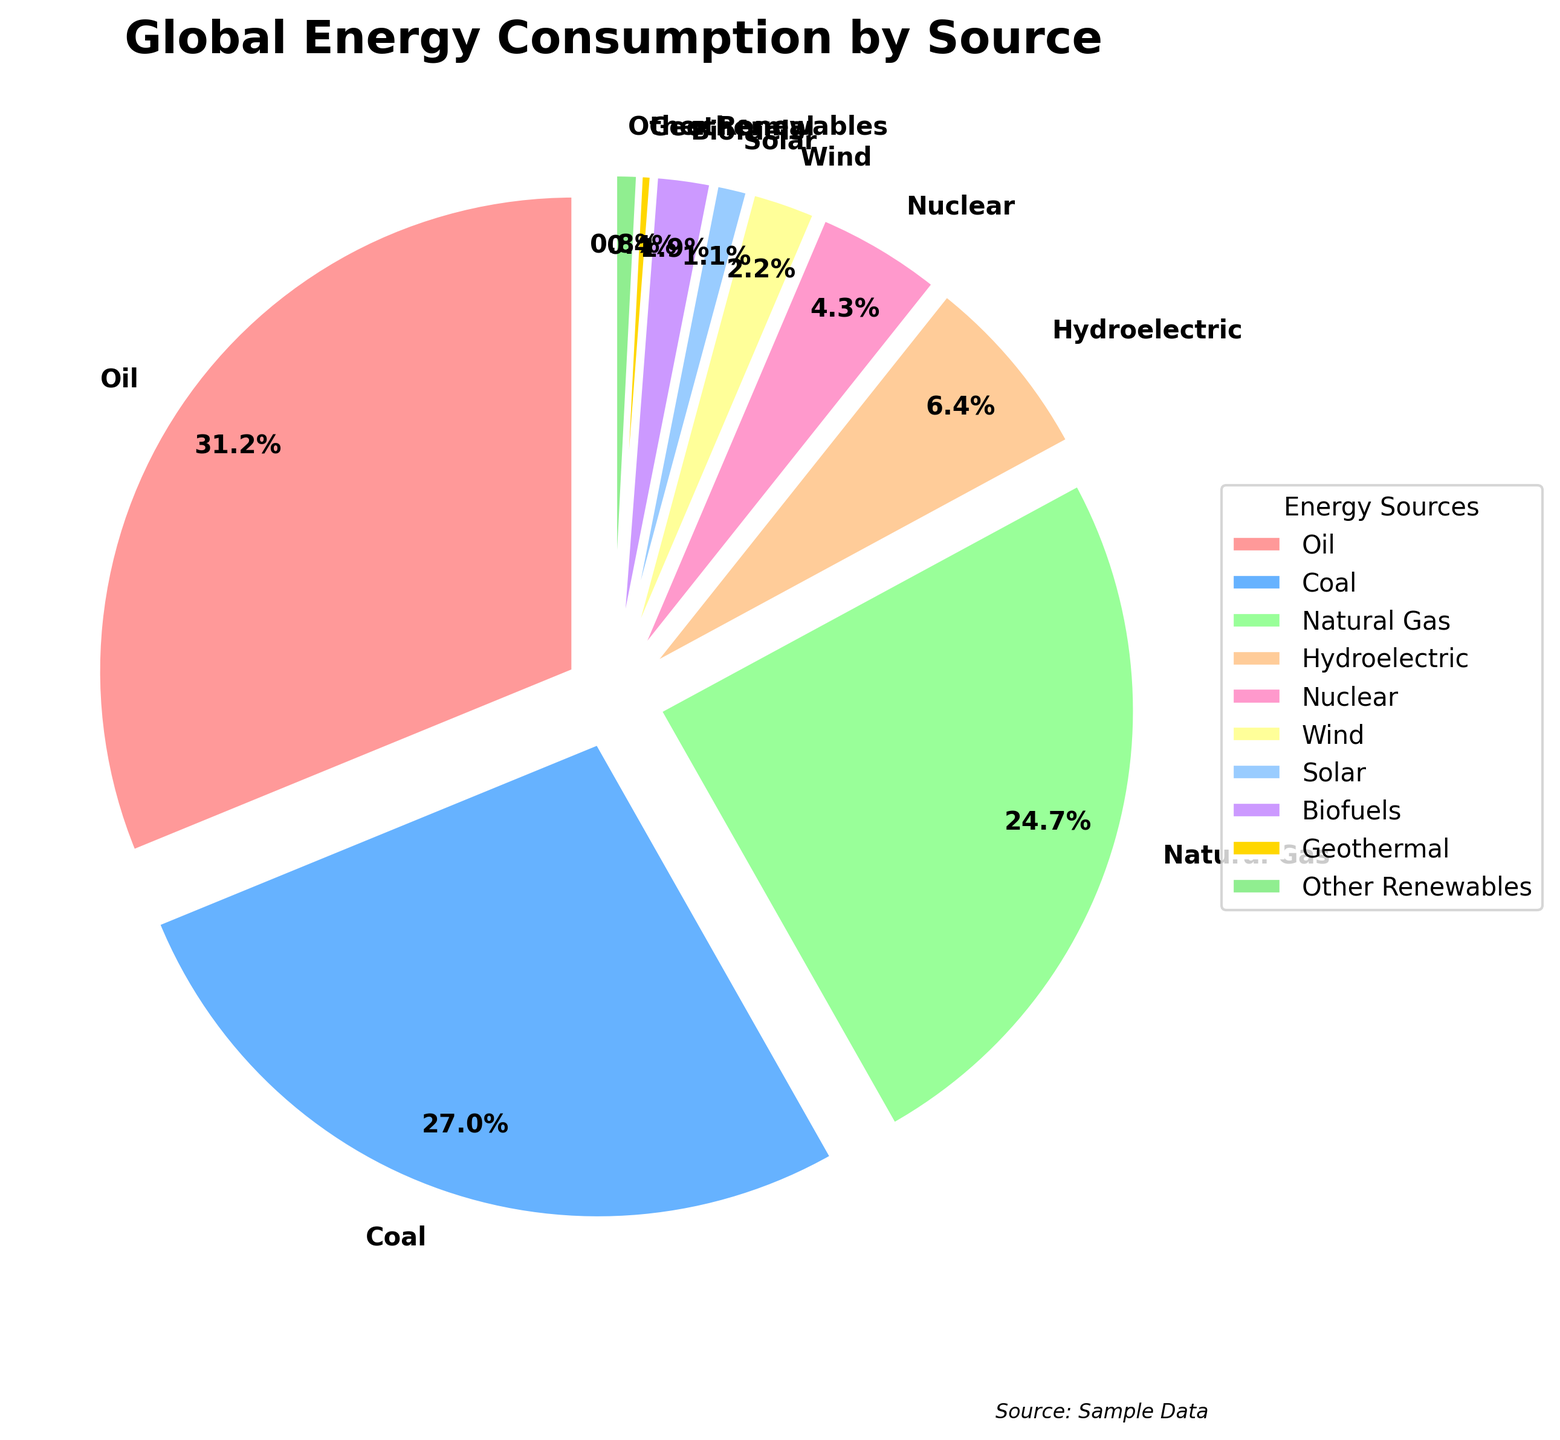Which energy source has the largest percentage of global consumption? The figure shows a pie chart where each slice represents an energy source, and the slice labeled 'Oil' is the largest.
Answer: Oil What's the combined percentage of global energy consumption for wind and solar energy? The figure shows the percentages for wind and solar energy as 2.2% and 1.1%, respectively. Adding these gives 2.2% + 1.1% = 3.3%.
Answer: 3.3% Which energy source contributes more to global energy consumption, nuclear or hydroelectric? The pie chart labels show 4.3% for nuclear and 6.4% for hydroelectric. Since 6.4% is greater than 4.3%, hydroelectric contributes more.
Answer: Hydroelectric How much less is the percentage of energy consumption by biofuels compared to coal? The figure labels show the percentages as 1.9% for biofuels and 27.0% for coal. Subtracting these gives 27.0% - 1.9% = 25.1%.
Answer: 25.1% Arrange the energy sources in descending order of their contribution to global energy consumption. The pie chart shows the percentages next to labels. Arranging from largest to smallest gives: Oil, Coal, Natural Gas, Hydroelectric, Nuclear, Wind, Biofuels, Solar, Other Renewables, Geothermal.
Answer: Oil, Coal, Natural Gas, Hydroelectric, Nuclear, Wind, Biofuels, Solar, Other Renewables, Geothermal If 'Other Renewables' and 'Geothermal' are combined, what would be their total percentage in the pie chart? The figure shows the percentages as 0.8% for Other Renewables and 0.4% for Geothermal. Adding these gives 0.8% + 0.4% = 1.2%.
Answer: 1.2% What's the difference between the energy consumption percentages of natural gas and wind energy? The pie chart shows the percentages as 24.7% for natural gas and 2.2% for wind. Subtracting these gives 24.7% - 2.2% = 22.5%.
Answer: 22.5% Which energy source is represented by the light blue section of the pie chart? The light blue section of the pie chart has the label 'Coal'.
Answer: Coal How many energy sources have a share of less than 2%? The pie chart segments with less than 2% are Wind (2.2%), Solar (1.1%), Biofuels (1.9%), Geothermal (0.4%), and Other Renewables (0.8%). There are 5 such sources.
Answer: 5 What is the percentage difference between the largest and the smallest energy source categories? The largest is Oil at 31.2% and the smallest is Geothermal at 0.4%. The difference is 31.2% - 0.4% = 30.8%.
Answer: 30.8% 